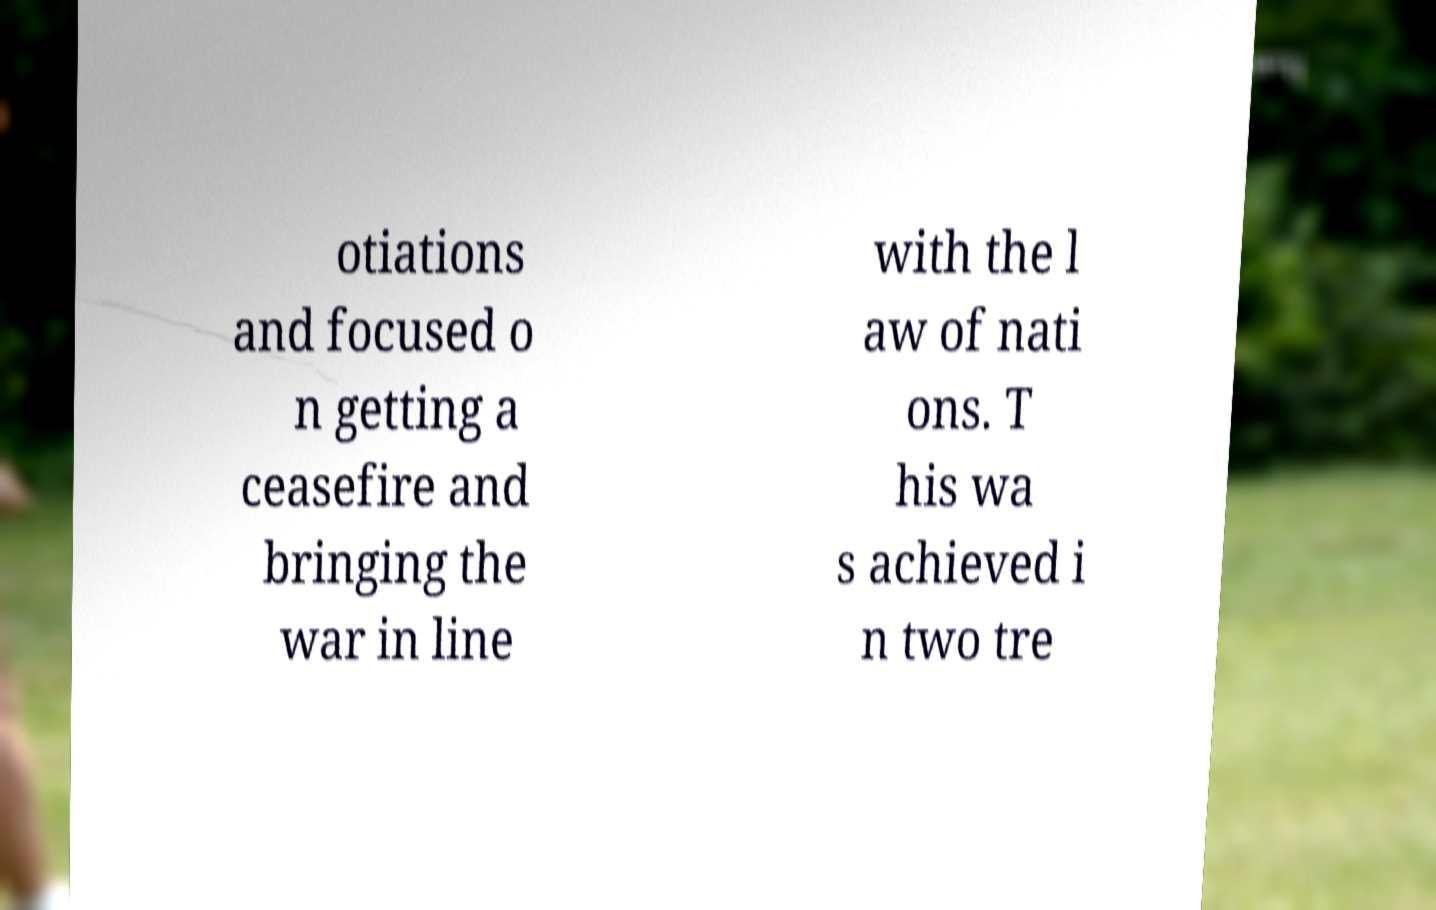Please read and relay the text visible in this image. What does it say? otiations and focused o n getting a ceasefire and bringing the war in line with the l aw of nati ons. T his wa s achieved i n two tre 